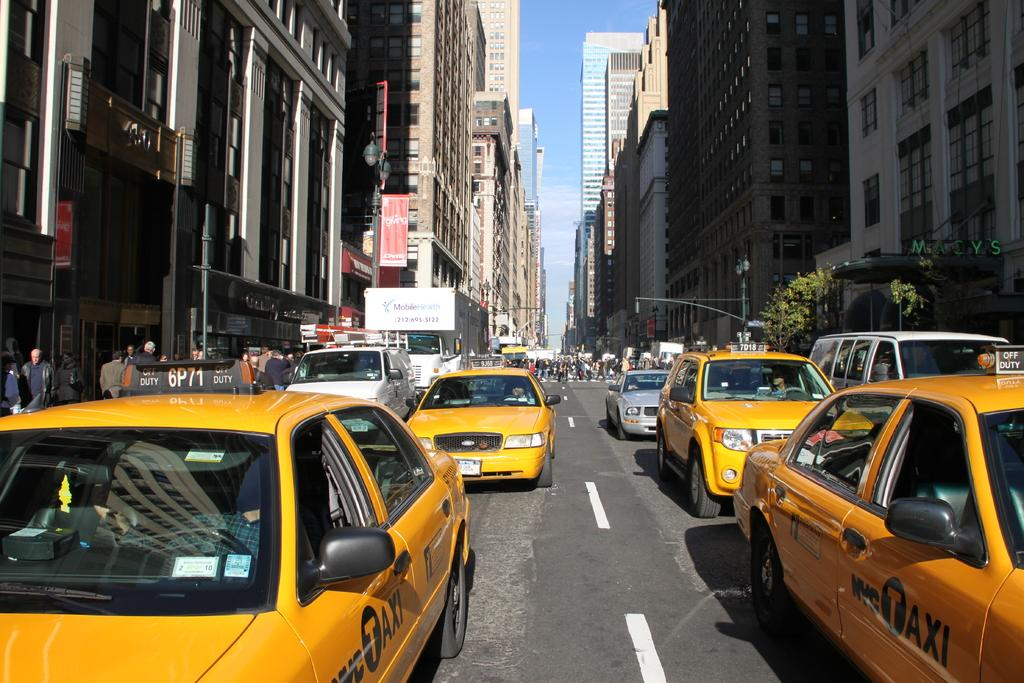<image>
Describe the image concisely. Several NYC Taxis are bumper to bumper in traffic. 